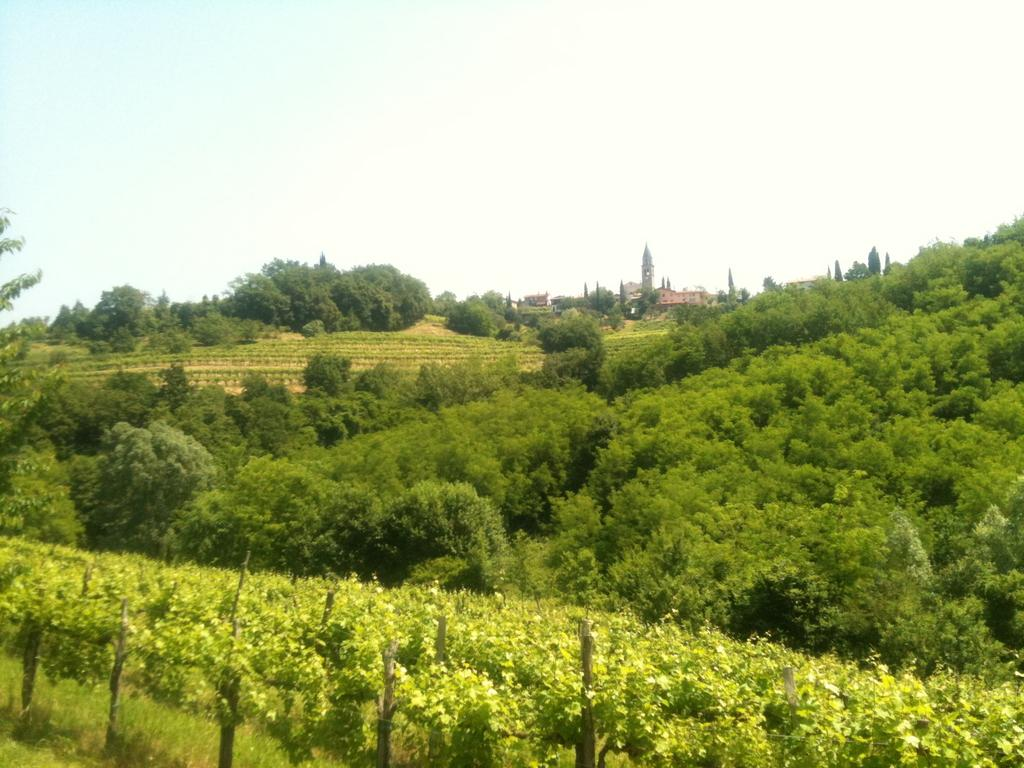What type of vegetation can be seen in the image? There are trees and plants in the image. Where are the trees and plants located? The trees and plants are on a hill. What is visible at the top of the image? The sky is visible at the top of the image. What type of ball is being used in the protest in the image? There is no protest or ball present in the image; it features trees and plants on a hill with a visible sky. 